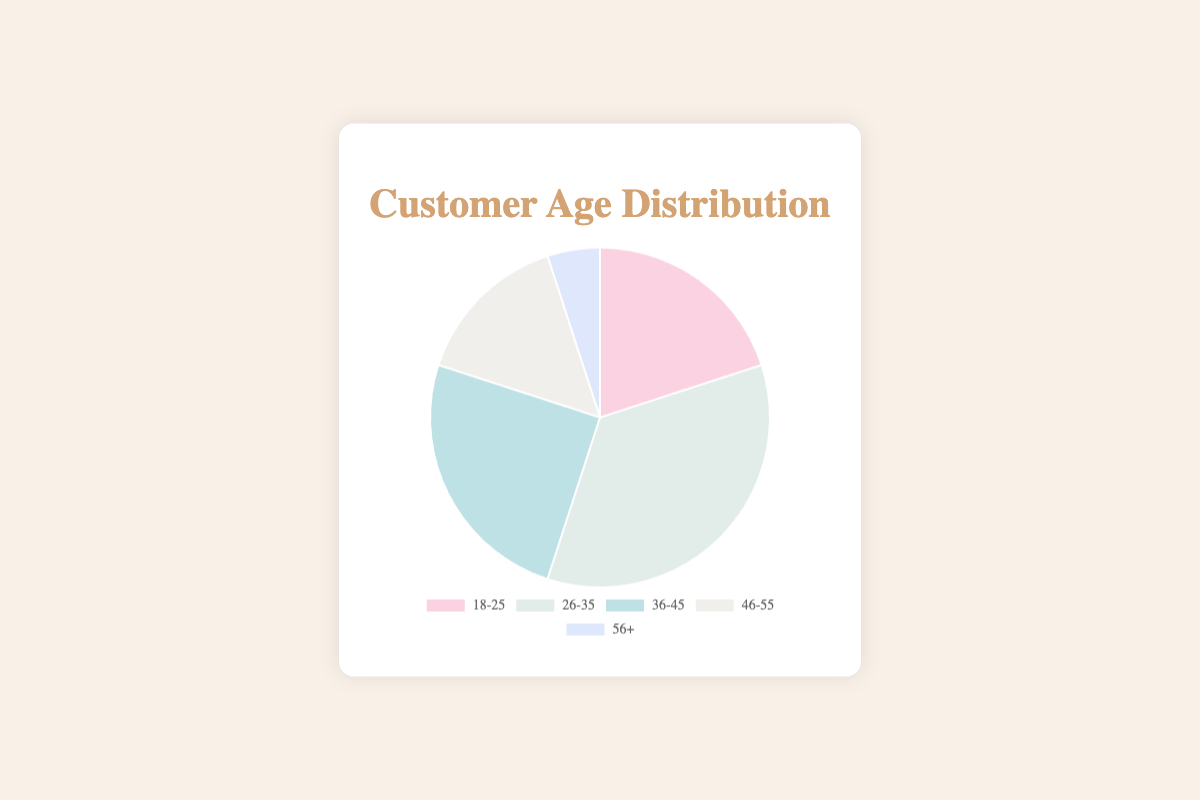What's the age group with the highest customer percentage? Look for the segment with the largest share in the pie chart. The 26-35 age group has the largest section.
Answer: 26-35 How many more customers are there in the 26-35 age group compared to the 56+ age group? Subtract the 56+ count (5) from the 26-35 count (35). 35 - 5 = 30
Answer: 30 What is the combined percentage of customers in the 18-25 and 36-45 age groups? Add the percentages of both age groups: 20% (18-25) + 25% (36-45). 20 + 25 = 45%
Answer: 45% Which age group has the smallest representation in the customer base? Identify the segment with the smallest slice in the pie chart. The 56+ age group has the smallest segment.
Answer: 56+ Is the 26-35 age group larger than the sum of the 46-55 and 56+ age groups? Add the percentages of 46-55 and 56+ age groups: 15% + 5% = 20%. Compare to 26-35's 35%. 35% > 20%
Answer: Yes What is the visual color of the 36-45 age group segment? Refer to the color represented in the pie chart for the 36-45 age group which is usually shown in legend or color key.
Answer: Light blue What is the total percentage of customers aged 36-55? Add the percentages of 36-45 and 46-55 age groups: 25% + 15%. 25 + 15 = 40%
Answer: 40% What age group comes second in customer percentage? Find the second largest segment in the pie chart after the largest (26-35). The 36-45 age group has the second largest section.
Answer: 36-45 Does the 18-25 age group have more customers than the 46-55 age group? Compare the percentages of 18-25 (20%) and 46-55 (15%) age groups. 20% > 15%
Answer: Yes 